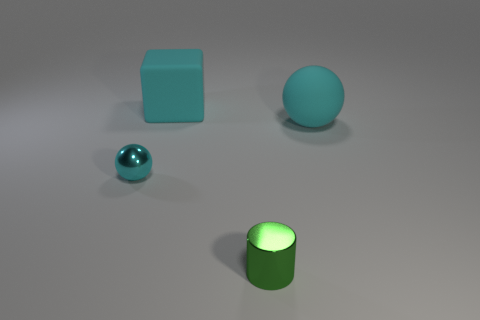What materials are represented by the objects in the image? The objects depicted in the image seem to showcase at least two different materials. One object appears to have a metallic sheen, indicative of a metal material, while the others exhibit a matte finish, which would suggest a non-reflective surface, possibly plastic or some form of matte paint. 